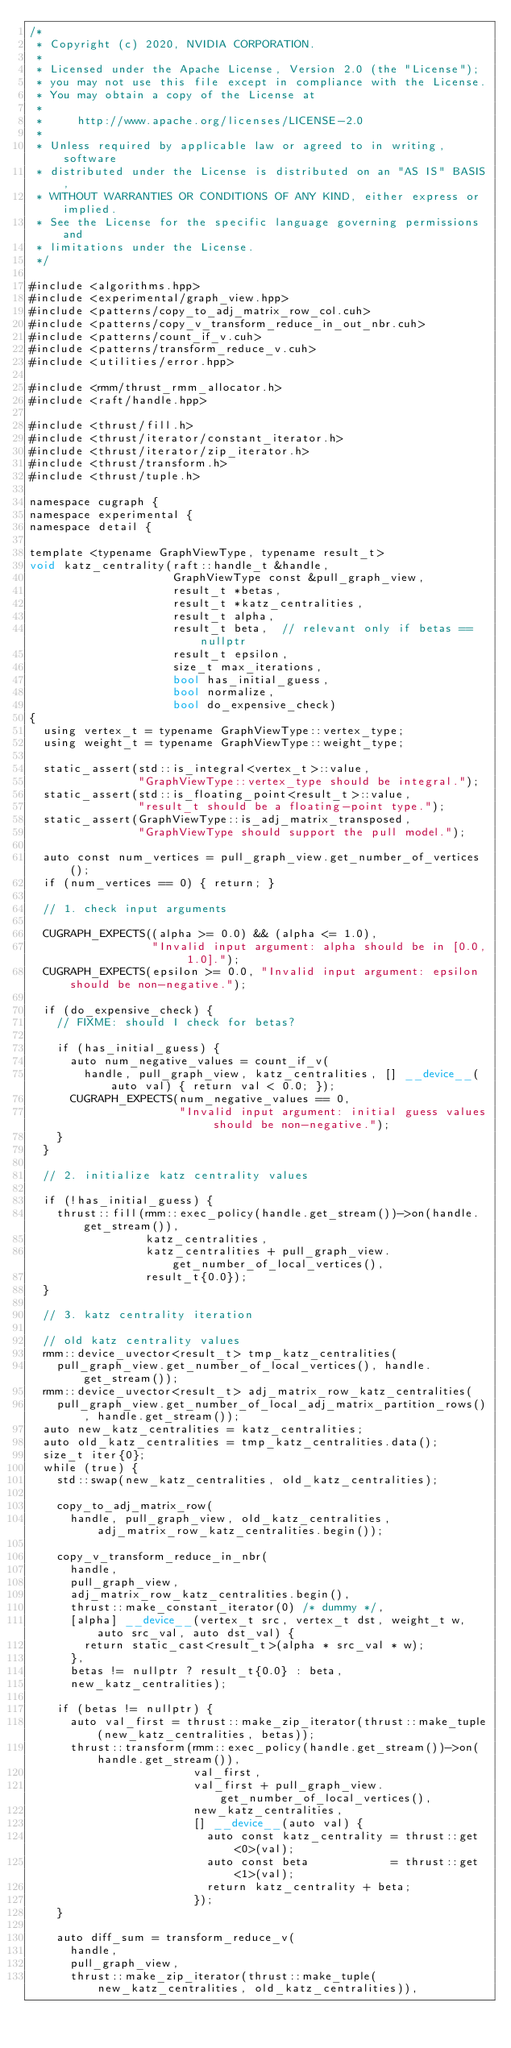Convert code to text. <code><loc_0><loc_0><loc_500><loc_500><_Cuda_>/*
 * Copyright (c) 2020, NVIDIA CORPORATION.
 *
 * Licensed under the Apache License, Version 2.0 (the "License");
 * you may not use this file except in compliance with the License.
 * You may obtain a copy of the License at
 *
 *     http://www.apache.org/licenses/LICENSE-2.0
 *
 * Unless required by applicable law or agreed to in writing, software
 * distributed under the License is distributed on an "AS IS" BASIS,
 * WITHOUT WARRANTIES OR CONDITIONS OF ANY KIND, either express or implied.
 * See the License for the specific language governing permissions and
 * limitations under the License.
 */

#include <algorithms.hpp>
#include <experimental/graph_view.hpp>
#include <patterns/copy_to_adj_matrix_row_col.cuh>
#include <patterns/copy_v_transform_reduce_in_out_nbr.cuh>
#include <patterns/count_if_v.cuh>
#include <patterns/transform_reduce_v.cuh>
#include <utilities/error.hpp>

#include <rmm/thrust_rmm_allocator.h>
#include <raft/handle.hpp>

#include <thrust/fill.h>
#include <thrust/iterator/constant_iterator.h>
#include <thrust/iterator/zip_iterator.h>
#include <thrust/transform.h>
#include <thrust/tuple.h>

namespace cugraph {
namespace experimental {
namespace detail {

template <typename GraphViewType, typename result_t>
void katz_centrality(raft::handle_t &handle,
                     GraphViewType const &pull_graph_view,
                     result_t *betas,
                     result_t *katz_centralities,
                     result_t alpha,
                     result_t beta,  // relevant only if betas == nullptr
                     result_t epsilon,
                     size_t max_iterations,
                     bool has_initial_guess,
                     bool normalize,
                     bool do_expensive_check)
{
  using vertex_t = typename GraphViewType::vertex_type;
  using weight_t = typename GraphViewType::weight_type;

  static_assert(std::is_integral<vertex_t>::value,
                "GraphViewType::vertex_type should be integral.");
  static_assert(std::is_floating_point<result_t>::value,
                "result_t should be a floating-point type.");
  static_assert(GraphViewType::is_adj_matrix_transposed,
                "GraphViewType should support the pull model.");

  auto const num_vertices = pull_graph_view.get_number_of_vertices();
  if (num_vertices == 0) { return; }

  // 1. check input arguments

  CUGRAPH_EXPECTS((alpha >= 0.0) && (alpha <= 1.0),
                  "Invalid input argument: alpha should be in [0.0, 1.0].");
  CUGRAPH_EXPECTS(epsilon >= 0.0, "Invalid input argument: epsilon should be non-negative.");

  if (do_expensive_check) {
    // FIXME: should I check for betas?

    if (has_initial_guess) {
      auto num_negative_values = count_if_v(
        handle, pull_graph_view, katz_centralities, [] __device__(auto val) { return val < 0.0; });
      CUGRAPH_EXPECTS(num_negative_values == 0,
                      "Invalid input argument: initial guess values should be non-negative.");
    }
  }

  // 2. initialize katz centrality values

  if (!has_initial_guess) {
    thrust::fill(rmm::exec_policy(handle.get_stream())->on(handle.get_stream()),
                 katz_centralities,
                 katz_centralities + pull_graph_view.get_number_of_local_vertices(),
                 result_t{0.0});
  }

  // 3. katz centrality iteration

  // old katz centrality values
  rmm::device_uvector<result_t> tmp_katz_centralities(
    pull_graph_view.get_number_of_local_vertices(), handle.get_stream());
  rmm::device_uvector<result_t> adj_matrix_row_katz_centralities(
    pull_graph_view.get_number_of_local_adj_matrix_partition_rows(), handle.get_stream());
  auto new_katz_centralities = katz_centralities;
  auto old_katz_centralities = tmp_katz_centralities.data();
  size_t iter{0};
  while (true) {
    std::swap(new_katz_centralities, old_katz_centralities);

    copy_to_adj_matrix_row(
      handle, pull_graph_view, old_katz_centralities, adj_matrix_row_katz_centralities.begin());

    copy_v_transform_reduce_in_nbr(
      handle,
      pull_graph_view,
      adj_matrix_row_katz_centralities.begin(),
      thrust::make_constant_iterator(0) /* dummy */,
      [alpha] __device__(vertex_t src, vertex_t dst, weight_t w, auto src_val, auto dst_val) {
        return static_cast<result_t>(alpha * src_val * w);
      },
      betas != nullptr ? result_t{0.0} : beta,
      new_katz_centralities);

    if (betas != nullptr) {
      auto val_first = thrust::make_zip_iterator(thrust::make_tuple(new_katz_centralities, betas));
      thrust::transform(rmm::exec_policy(handle.get_stream())->on(handle.get_stream()),
                        val_first,
                        val_first + pull_graph_view.get_number_of_local_vertices(),
                        new_katz_centralities,
                        [] __device__(auto val) {
                          auto const katz_centrality = thrust::get<0>(val);
                          auto const beta            = thrust::get<1>(val);
                          return katz_centrality + beta;
                        });
    }

    auto diff_sum = transform_reduce_v(
      handle,
      pull_graph_view,
      thrust::make_zip_iterator(thrust::make_tuple(new_katz_centralities, old_katz_centralities)),</code> 